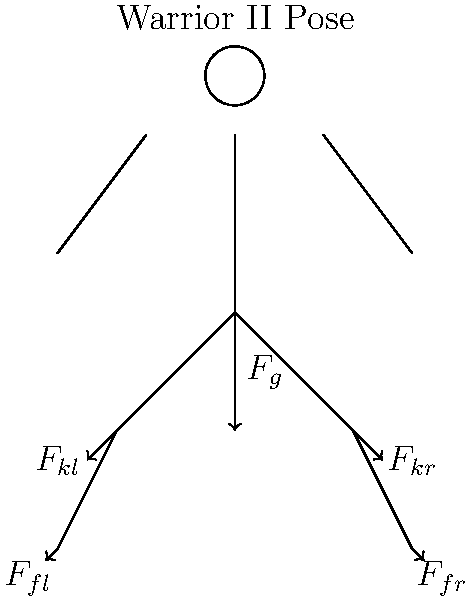In the Warrior II yoga pose, as illustrated in the free body diagram, compare the magnitude of the force exerted on the front knee joint ($F_{kr}$) to the force exerted on the back knee joint ($F_{kl}$). Assume the practitioner's weight is evenly distributed between both legs, and the front leg is bent at a 90-degree angle while the back leg is straight. Which knee joint experiences a greater force, and why? To compare the forces on the knee joints in the Warrior II pose, we need to consider the following factors:

1. Weight distribution: The practitioner's weight is evenly distributed between both legs.

2. Leg positions:
   - Front leg (right): Bent at a 90-degree angle
   - Back leg (left): Straight

3. Force analysis:
   a) For the front (right) leg:
      - The bent knee creates a moment arm, increasing the force on the joint.
      - Force direction is not aligned with the leg, creating shear and compressive components.
   
   b) For the back (left) leg:
      - The straight leg allows for more efficient force transfer.
      - Force is mostly aligned with the leg, primarily creating a compressive force.

4. Biomechanical principle: In a bent joint, the force required to maintain position is greater than in a straight joint due to the increased moment arm.

5. Calculation (simplified):
   Let $F_g$ be half of the body weight (as weight is evenly distributed).
   
   For the front knee: $F_{kr} = \frac{F_g}{\cos \theta}$, where $\theta$ is the angle between the lower leg and the vertical (45° in this case).
   
   For the back knee: $F_{kl} \approx F_g$ (slightly more due to the angle of the leg)

   $F_{kr} = \frac{F_g}{\cos 45°} \approx 1.414F_g$

Therefore, the force on the front knee ($F_{kr}$) is greater than the force on the back knee ($F_{kl}$).
Answer: The front knee joint experiences a greater force due to the bent position creating a larger moment arm and less efficient force transfer. 